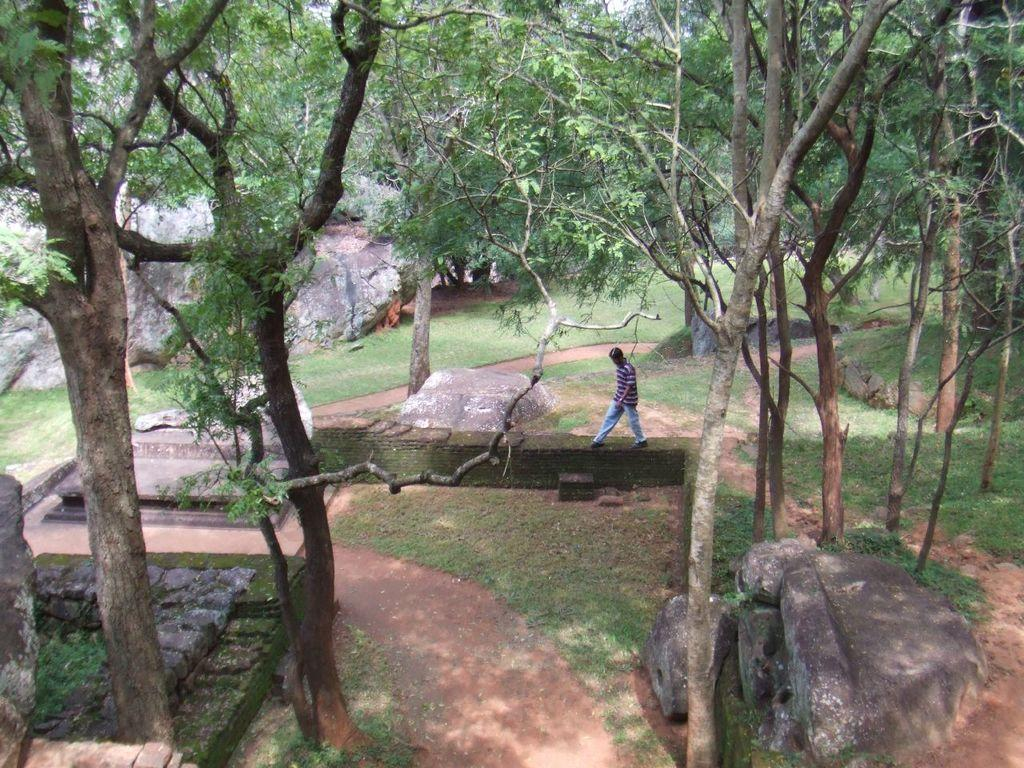What is the person in the image doing? There is a person walking in the image. What type of vegetation can be seen in the image? There are trees in the image, and their bark is visible. What type of ground cover is present in the image? There is grass in the image. What type of natural feature can be seen in the image? There is a rock in the image. What type of material is present in the image? Stones are present in the image. What is visible in the background of the image? The sky is visible in the image. How does the person in the image begin to join the top of the trees? There is no indication in the image that the person is attempting to join the top of the trees. 